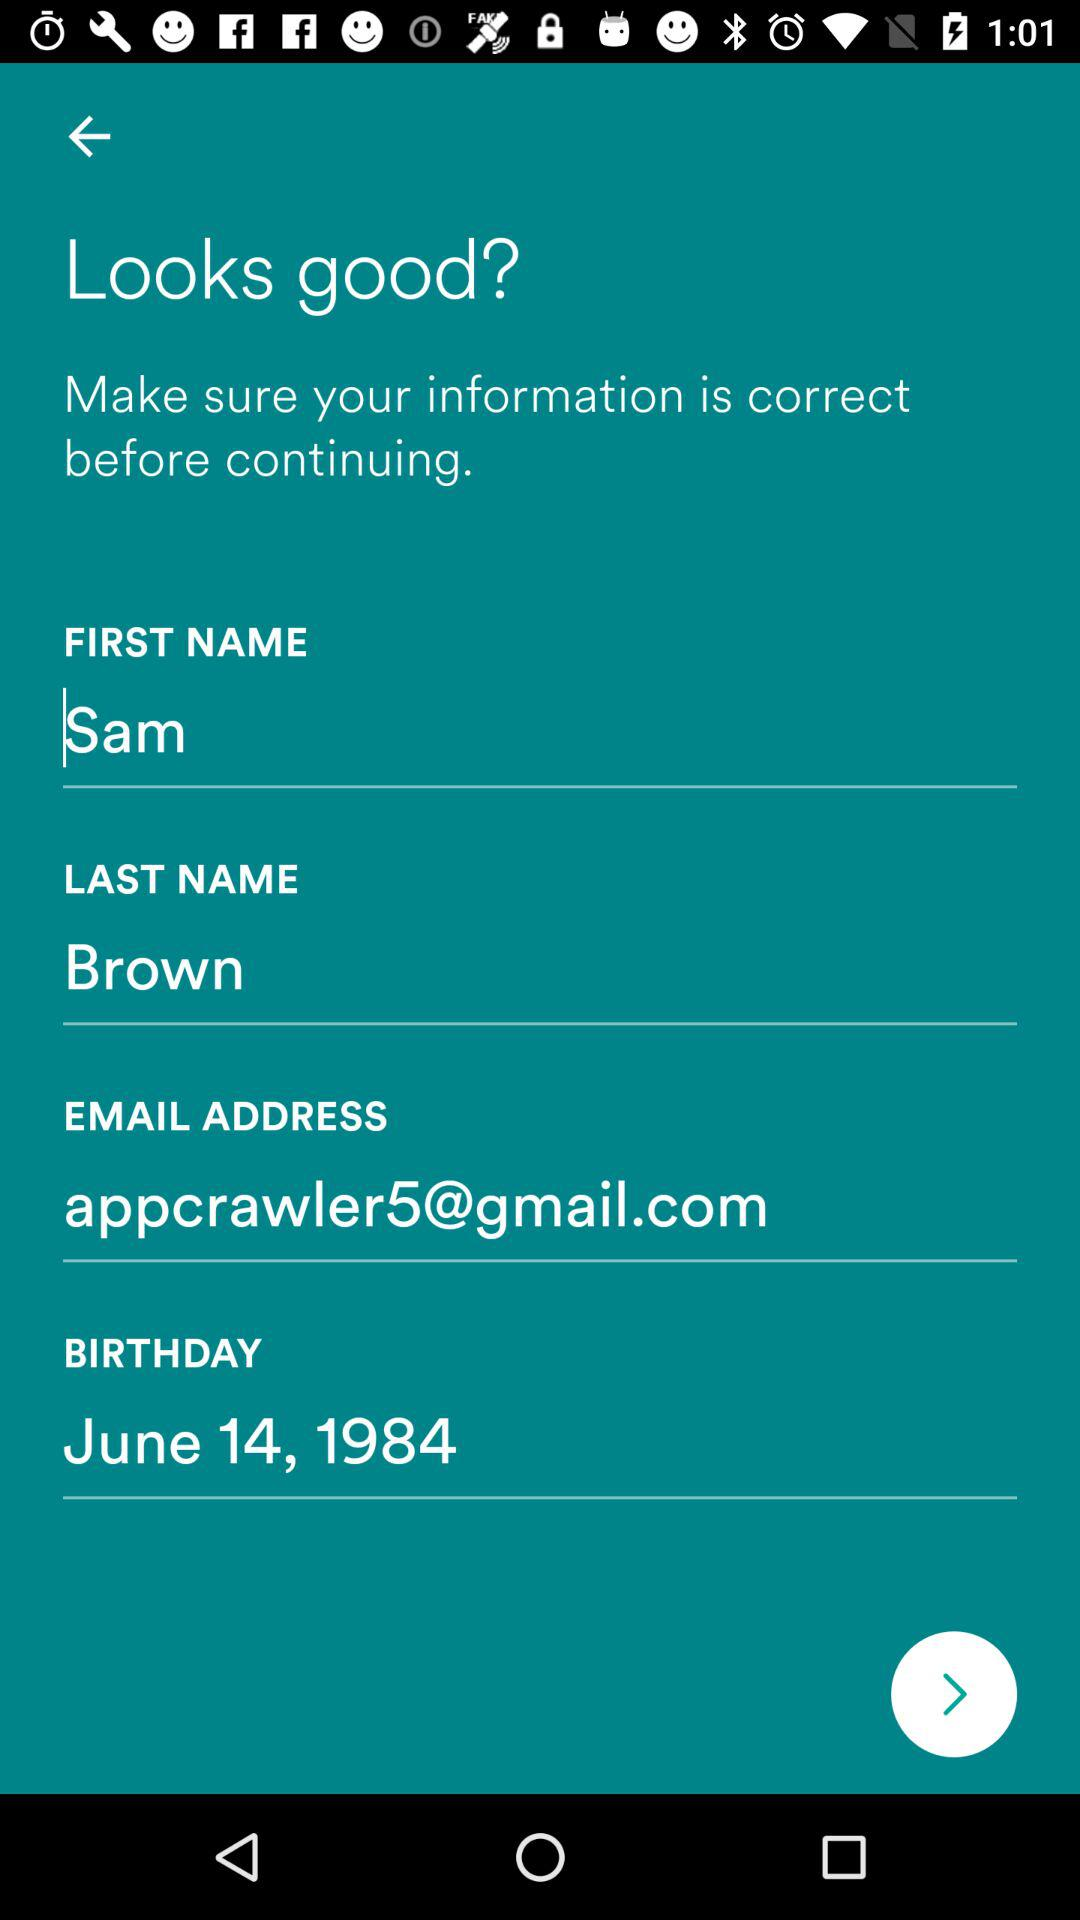What is the date of birth of Sam? The date of birth is June 14, 1984. 